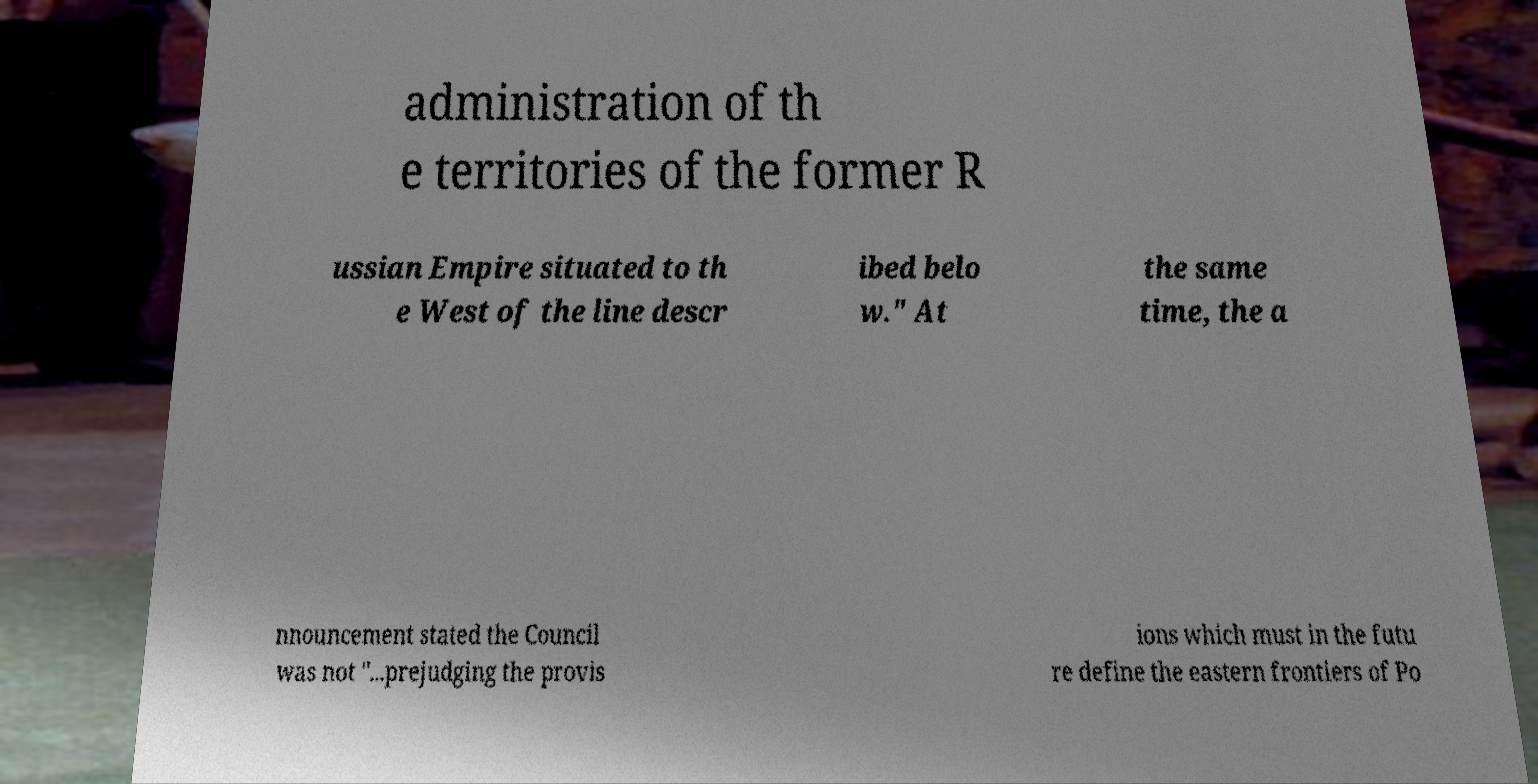There's text embedded in this image that I need extracted. Can you transcribe it verbatim? administration of th e territories of the former R ussian Empire situated to th e West of the line descr ibed belo w." At the same time, the a nnouncement stated the Council was not "...prejudging the provis ions which must in the futu re define the eastern frontiers of Po 